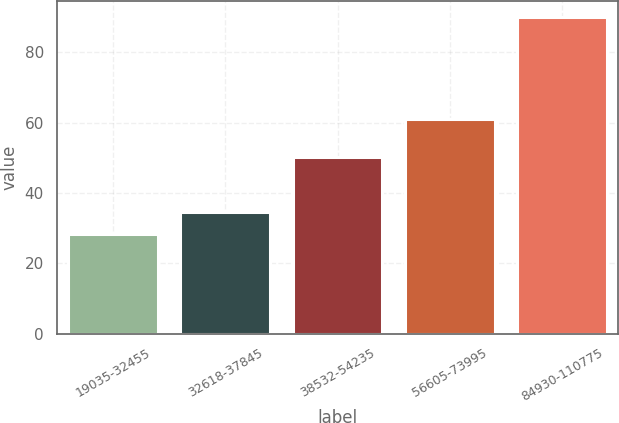<chart> <loc_0><loc_0><loc_500><loc_500><bar_chart><fcel>19035-32455<fcel>32618-37845<fcel>38532-54235<fcel>56605-73995<fcel>84930-110775<nl><fcel>28.35<fcel>34.51<fcel>50.11<fcel>60.88<fcel>89.96<nl></chart> 